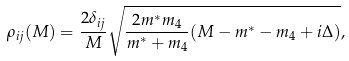Convert formula to latex. <formula><loc_0><loc_0><loc_500><loc_500>\rho _ { i j } ( M ) = \frac { 2 \delta _ { i j } } { M } \sqrt { \frac { 2 m ^ { * } m _ { 4 } } { m ^ { * } + m _ { 4 } } ( M - m ^ { * } - m _ { 4 } + i \Delta ) } ,</formula> 